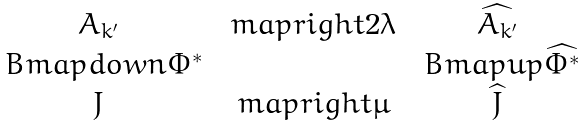<formula> <loc_0><loc_0><loc_500><loc_500>\begin{matrix} A _ { k ^ { \prime } } & \ m a p r i g h t { 2 \lambda } & \widehat { A _ { k ^ { \prime } } } \\ \ B m a p d o w n { \Phi ^ { * } } & & \ B m a p u p { \widehat { \Phi ^ { * } } } \\ J & \ m a p r i g h t { \mu } & \widehat { J } \end{matrix}</formula> 